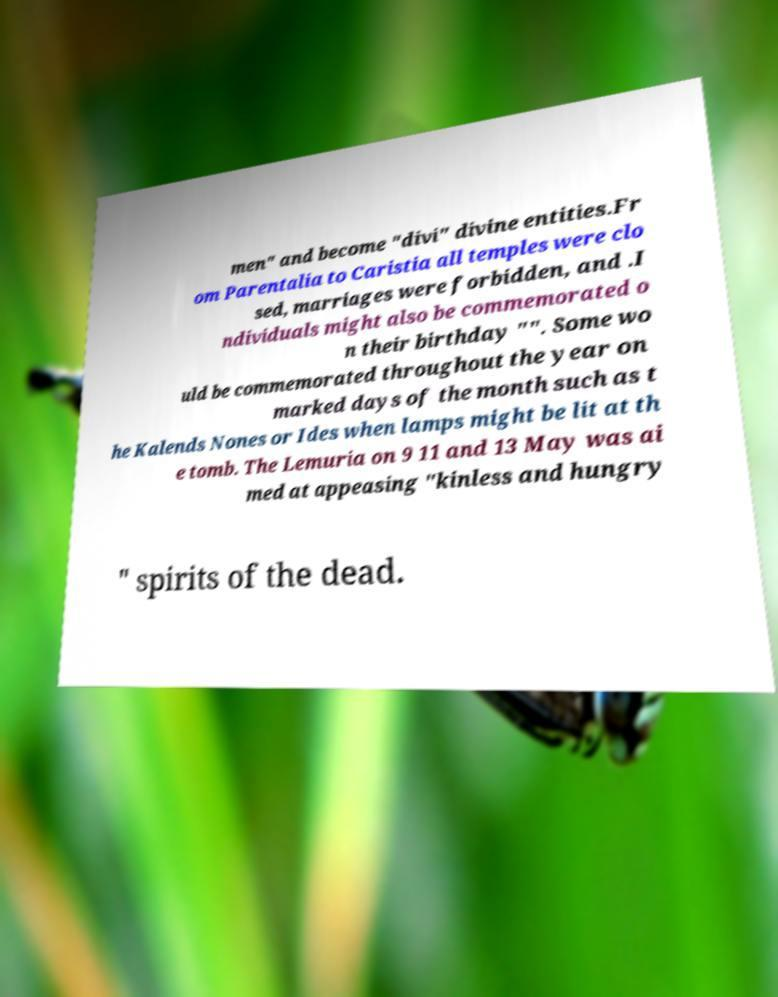Could you extract and type out the text from this image? men" and become "divi" divine entities.Fr om Parentalia to Caristia all temples were clo sed, marriages were forbidden, and .I ndividuals might also be commemorated o n their birthday "". Some wo uld be commemorated throughout the year on marked days of the month such as t he Kalends Nones or Ides when lamps might be lit at th e tomb. The Lemuria on 9 11 and 13 May was ai med at appeasing "kinless and hungry " spirits of the dead. 